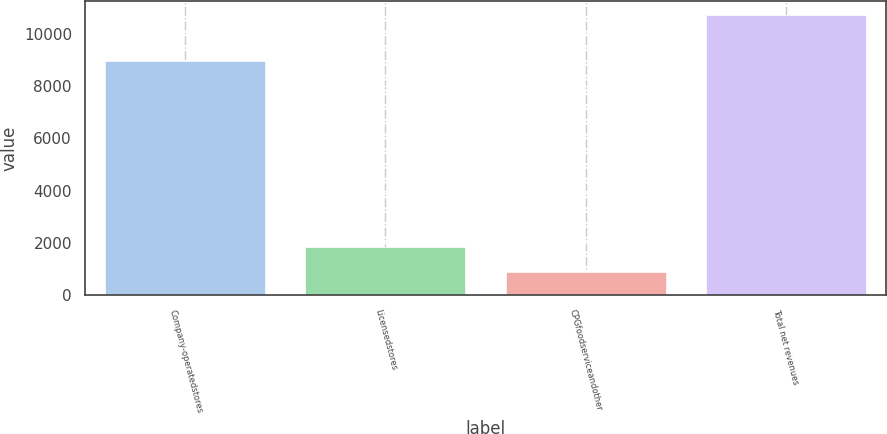<chart> <loc_0><loc_0><loc_500><loc_500><bar_chart><fcel>Company-operatedstores<fcel>Licensedstores<fcel>CPGfoodserviceandother<fcel>Total net revenues<nl><fcel>8963.5<fcel>1852.57<fcel>868.7<fcel>10707.4<nl></chart> 